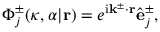Convert formula to latex. <formula><loc_0><loc_0><loc_500><loc_500>\Phi _ { j } ^ { \pm } ( \kappa , \alpha | r ) = e ^ { i k ^ { \pm } \cdot r } \hat { e } _ { j } ^ { \pm } ,</formula> 